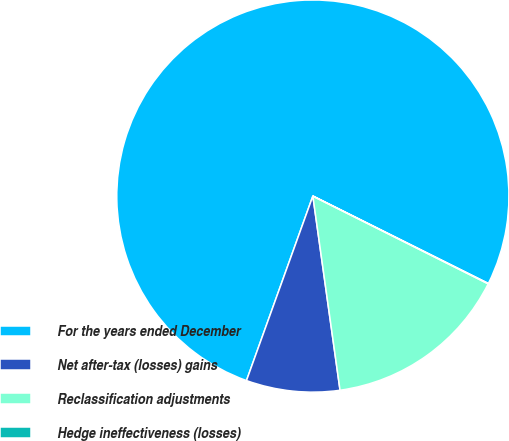Convert chart. <chart><loc_0><loc_0><loc_500><loc_500><pie_chart><fcel>For the years ended December<fcel>Net after-tax (losses) gains<fcel>Reclassification adjustments<fcel>Hedge ineffectiveness (losses)<nl><fcel>76.86%<fcel>7.71%<fcel>15.4%<fcel>0.03%<nl></chart> 